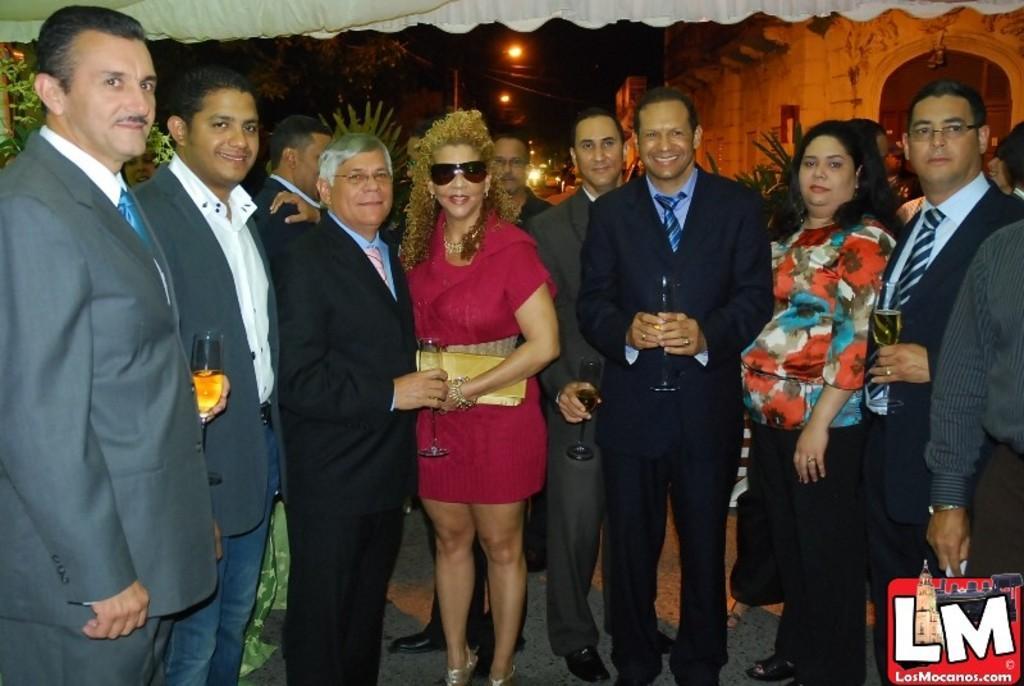Could you give a brief overview of what you see in this image? In this image I can see in the middle a woman is standing, she wear a dress, goggles. Beside her a man is standing by holding a wine glass in his hand, around him a group of people are standing. At the top there are lights, in the right hand side bottom there is the logo. 